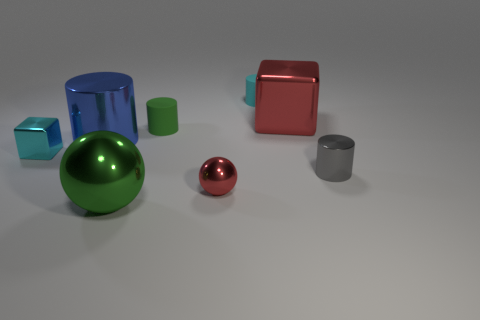Is the large metal cube the same color as the big cylinder?
Make the answer very short. No. The tiny cyan thing that is behind the tiny metal object left of the green rubber cylinder is made of what material?
Make the answer very short. Rubber. What size is the cyan matte cylinder?
Provide a succinct answer. Small. There is a gray thing that is the same material as the cyan cube; what is its size?
Your response must be concise. Small. There is a ball behind the green metal object; is it the same size as the gray cylinder?
Your answer should be very brief. Yes. What is the shape of the tiny matte thing in front of the small cyan object that is behind the red thing that is to the right of the tiny cyan cylinder?
Your answer should be compact. Cylinder. How many things are gray shiny cylinders or shiny things that are in front of the tiny gray metal cylinder?
Provide a succinct answer. 3. There is a red thing that is in front of the tiny green object; how big is it?
Your answer should be very brief. Small. The matte thing that is the same color as the tiny metallic block is what shape?
Offer a terse response. Cylinder. Are the large cylinder and the small object on the left side of the big green sphere made of the same material?
Make the answer very short. Yes. 